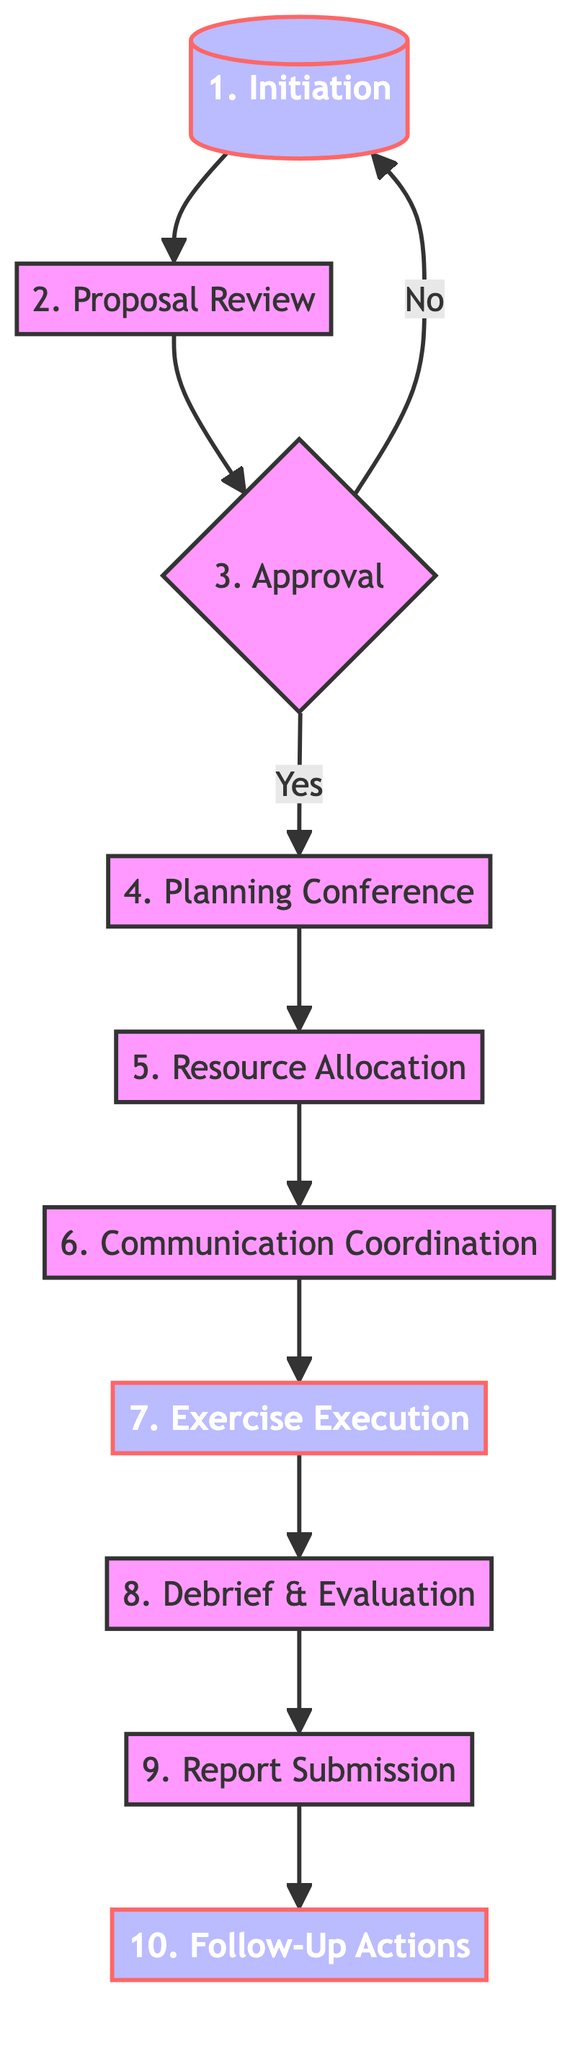What is the first step in the procedure? The first step in the procedure is titled "Initiation," where a member nation proposes the joint military exercise through the ASEAN Defence Ministers' Meeting (ADMM).
Answer: Initiation How many steps are in the procedure? Counting from Initiation to Follow-Up Actions, there are a total of 10 steps in the procedure as outlined in the diagram.
Answer: 10 What happens if the proposal is not approved? If the proposal is not approved, the flow goes back to the first step, which is "Initiation." This indicates that the proposal may need to be revised or re-proposed by the member nation.
Answer: Initiation What is established during the Communication Coordination step? During the Communication Coordination step, a Joint Communication Center (JCC) is established to ensure seamless, secure communication among participating nations.
Answer: Joint Communication Center What is the last step of the procedure? The last step in the procedure is titled "Follow-Up Actions," where actions are implemented based on the decisions made by the ADMM regarding improvements and future operational enhancements.
Answer: Follow-Up Actions What is the main focus during the Debrief & Evaluation step? The main focus during the Debrief & Evaluation step is to conduct a post-exercise debrief involving all participating states to evaluate outcomes and identify areas for improvement.
Answer: Evaluate outcomes What is required for a proposal to move to the Planning Conference step? For a proposal to move to the Planning Conference step, it must receive unanimous approval from all ASEAN member states. This is indicated in the "3. Approval" step.
Answer: Unanimous approval Which step involves resource commitment from member states? The step that involves resource commitment from member states is titled "Resource Allocation," where they agree to provide necessary resources such as troops, equipment, and financial support.
Answer: Resource Allocation What is the role of the ASEAN Peacekeeping Centre during the exercise? The role of the ASEAN Peacekeeping Centre during the exercise is to conduct real-time monitoring to ensure the exercise follows the agreed plan.
Answer: Real-time monitoring 